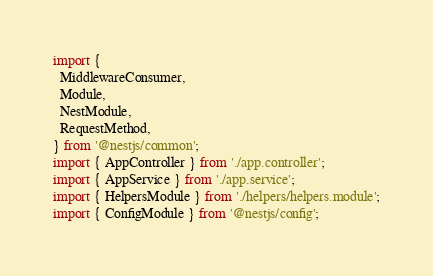<code> <loc_0><loc_0><loc_500><loc_500><_TypeScript_>import {
  MiddlewareConsumer,
  Module,
  NestModule,
  RequestMethod,
} from '@nestjs/common';
import { AppController } from './app.controller';
import { AppService } from './app.service';
import { HelpersModule } from './helpers/helpers.module';
import { ConfigModule } from '@nestjs/config';</code> 